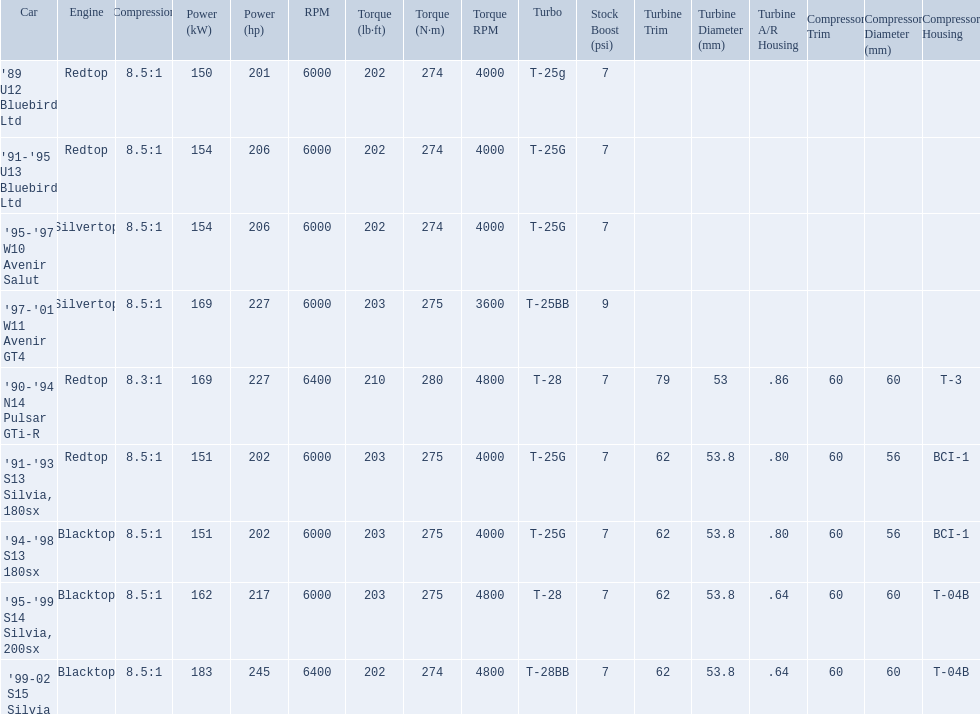What are all of the cars? '89 U12 Bluebird Ltd, '91-'95 U13 Bluebird Ltd, '95-'97 W10 Avenir Salut, '97-'01 W11 Avenir GT4, '90-'94 N14 Pulsar GTi-R, '91-'93 S13 Silvia, 180sx, '94-'98 S13 180sx, '95-'99 S14 Silvia, 200sx, '99-02 S15 Silvia. What is their rated power? 150 kW (201 hp) @ 6000 rpm, 154 kW (206 hp) @ 6000 rpm, 154 kW (206 hp) @ 6000 rpm, 169 kW (227 hp) @ 6000 rpm, 169 kW (227 hp) @ 6400 rpm (Euro: 164 kW (220 hp) @ 6400 rpm), 151 kW (202 hp) @ 6000 rpm, 151 kW (202 hp) @ 6000 rpm, 162 kW (217 hp) @ 6000 rpm, 183 kW (245 hp) @ 6400 rpm. Which car has the most power? '99-02 S15 Silvia. What cars are there? '89 U12 Bluebird Ltd, 7psi, '91-'95 U13 Bluebird Ltd, 7psi, '95-'97 W10 Avenir Salut, 7psi, '97-'01 W11 Avenir GT4, 9psi, '90-'94 N14 Pulsar GTi-R, 7psi, '91-'93 S13 Silvia, 180sx, 7psi, '94-'98 S13 180sx, 7psi, '95-'99 S14 Silvia, 200sx, 7psi, '99-02 S15 Silvia, 7psi. Which stock boost is over 7psi? '97-'01 W11 Avenir GT4, 9psi. What car is it? '97-'01 W11 Avenir GT4. 